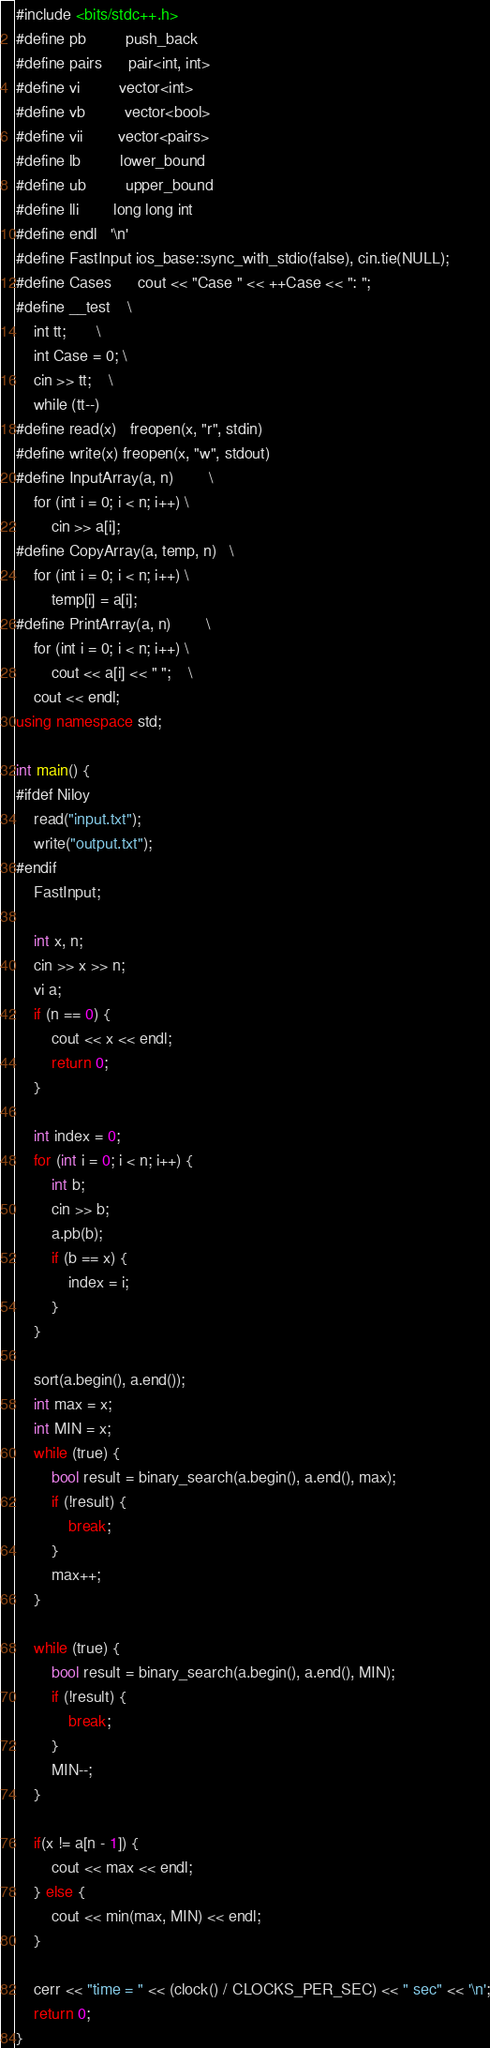Convert code to text. <code><loc_0><loc_0><loc_500><loc_500><_C++_>#include <bits/stdc++.h>
#define pb		  push_back
#define pairs	  pair<int, int>
#define vi		  vector<int>
#define vb		  vector<bool>
#define vii		  vector<pairs>
#define lb		  lower_bound
#define ub		  upper_bound
#define lli		  long long int
#define endl	  '\n'
#define FastInput ios_base::sync_with_stdio(false), cin.tie(NULL);
#define Cases	  cout << "Case " << ++Case << ": ";
#define __test    \
	int tt;       \
	int Case = 0; \
	cin >> tt;    \
	while (tt--)
#define read(x)	 freopen(x, "r", stdin)
#define write(x) freopen(x, "w", stdout)
#define InputArray(a, n)        \
	for (int i = 0; i < n; i++) \
		cin >> a[i];
#define CopyArray(a, temp, n)   \
	for (int i = 0; i < n; i++) \
		temp[i] = a[i];
#define PrintArray(a, n)        \
	for (int i = 0; i < n; i++) \
		cout << a[i] << " ";    \
	cout << endl;
using namespace std;

int main() {
#ifdef Niloy
	read("input.txt");
	write("output.txt");
#endif
	FastInput;

	int x, n;
	cin >> x >> n;
	vi a;
	if (n == 0) {
		cout << x << endl;
		return 0;
	}

	int index = 0;
	for (int i = 0; i < n; i++) {
		int b;
		cin >> b;
		a.pb(b);
		if (b == x) {
			index = i;
		}
	}

	sort(a.begin(), a.end());
	int max = x;
	int MIN = x;
	while (true) {
		bool result = binary_search(a.begin(), a.end(), max);
		if (!result) {
			break;
		}
		max++;
	}

	while (true) {
		bool result = binary_search(a.begin(), a.end(), MIN);
		if (!result) {
			break;
		}
		MIN--;
	}

	if(x != a[n - 1]) {
		cout << max << endl;
	} else {
		cout << min(max, MIN) << endl;
	}

	cerr << "time = " << (clock() / CLOCKS_PER_SEC) << " sec" << '\n';
	return 0;
}</code> 